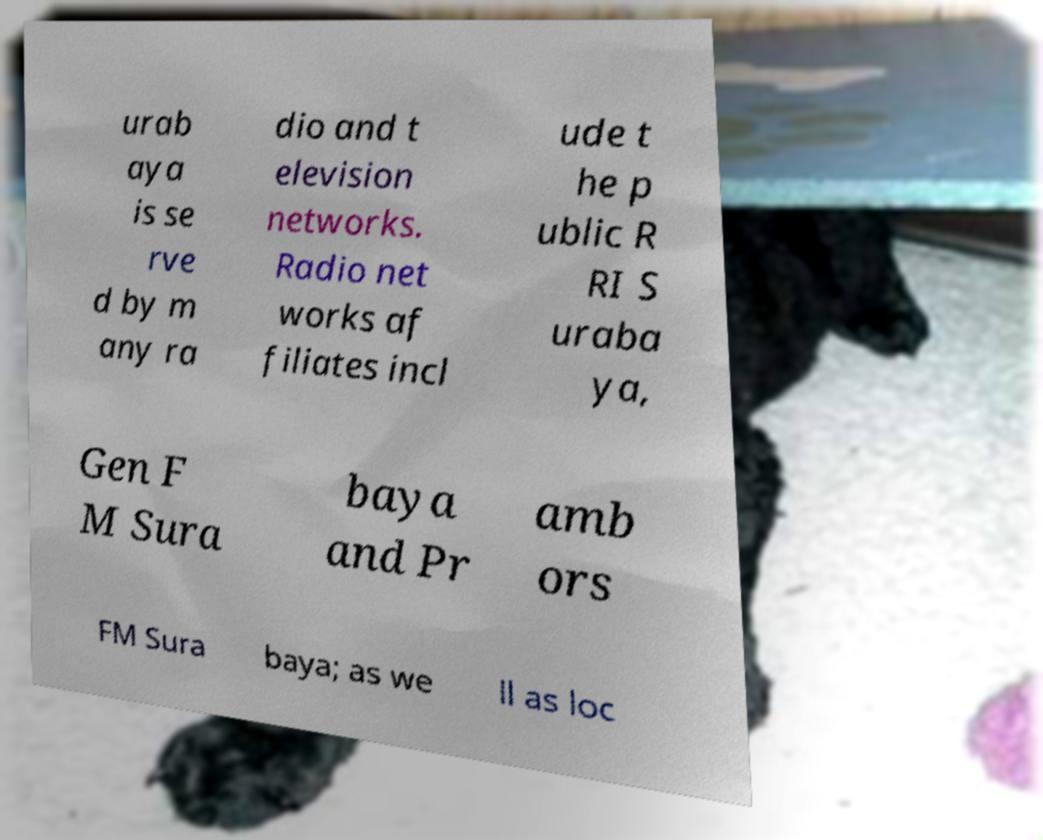There's text embedded in this image that I need extracted. Can you transcribe it verbatim? urab aya is se rve d by m any ra dio and t elevision networks. Radio net works af filiates incl ude t he p ublic R RI S uraba ya, Gen F M Sura baya and Pr amb ors FM Sura baya; as we ll as loc 